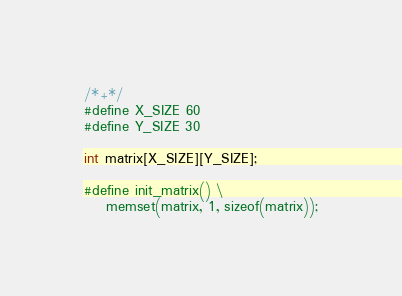Convert code to text. <code><loc_0><loc_0><loc_500><loc_500><_C_>/*+*/
#define X_SIZE 60
#define Y_SIZE 30

int matrix[X_SIZE][Y_SIZE];

#define init_matrix() \
    memset(matrix, 1, sizeof(matrix));
</code> 